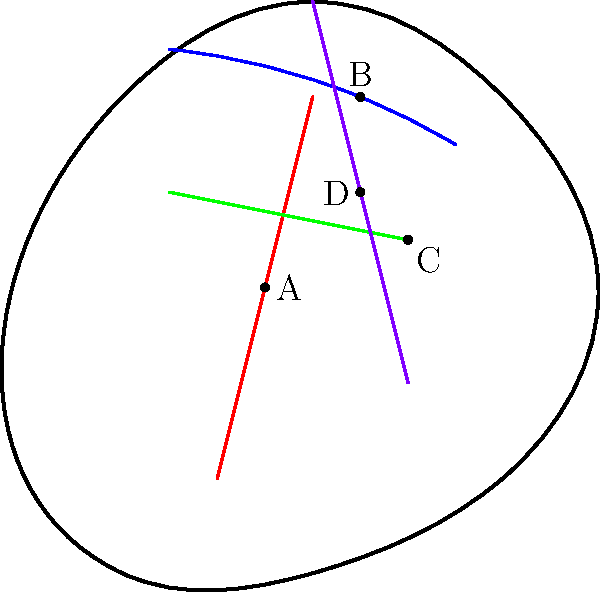In the detailed hand illustration above, four significant points (A, B, C, and D) are marked on different palm lines. Based on your expertise in palmistry, which point is most likely associated with a person's emotional stability and resilience, and why? To answer this question, we need to analyze each point and its corresponding line:

1. Point A: Located on the red line, which represents the Life Line. The Life Line is typically associated with vitality, physical health, and major life changes.

2. Point B: Situated on the blue line, which symbolizes the Heart Line. The Heart Line is related to emotional life, relationships, and love.

3. Point C: Found on the green line, representing the Head Line. The Head Line is connected to intellectual capabilities, communication style, and mental processes.

4. Point D: Positioned on the purple line, which indicates the Fate Line (also known as the Destiny Line). The Fate Line is associated with career path, life direction, and external influences on one's life.

In palmistry, emotional stability and resilience are most closely linked to the Heart Line (blue). The Heart Line reflects a person's emotional state, their ability to handle stress, and their overall emotional well-being.

Point B is located on the Heart Line, in the upper part of the palm. Its position near the fingers suggests a strong influence on the person's emotional life. In palmistry, a clear and well-defined Heart Line in this area often indicates good emotional balance and the ability to bounce back from emotional challenges.

Therefore, Point B is most likely associated with a person's emotional stability and resilience. Its prominent position on the Heart Line and proximity to the fingers suggest a strong emotional foundation and the capacity to maintain equilibrium in the face of life's ups and downs.
Answer: Point B 